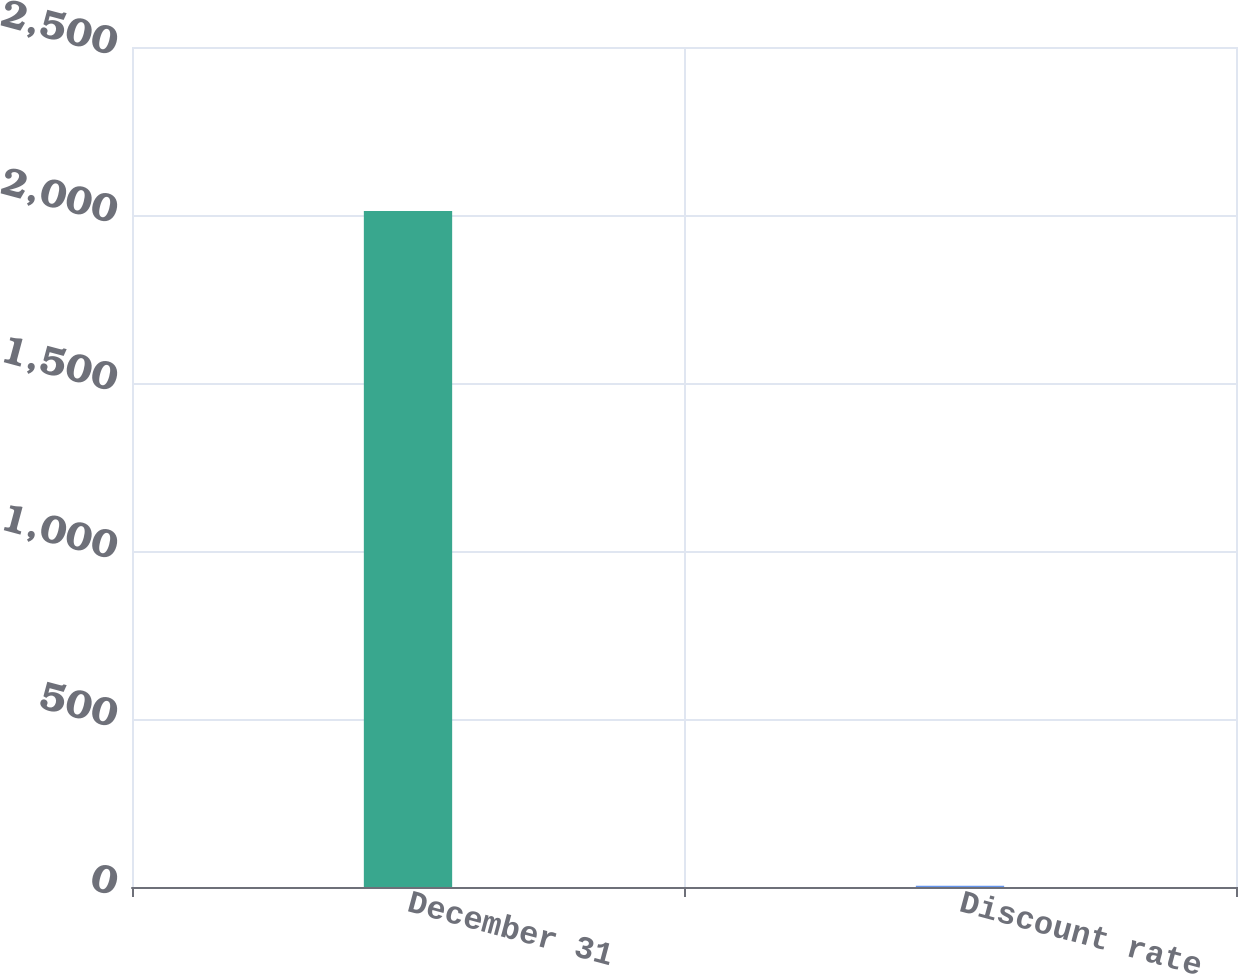Convert chart to OTSL. <chart><loc_0><loc_0><loc_500><loc_500><bar_chart><fcel>December 31<fcel>Discount rate<nl><fcel>2012<fcel>3.8<nl></chart> 